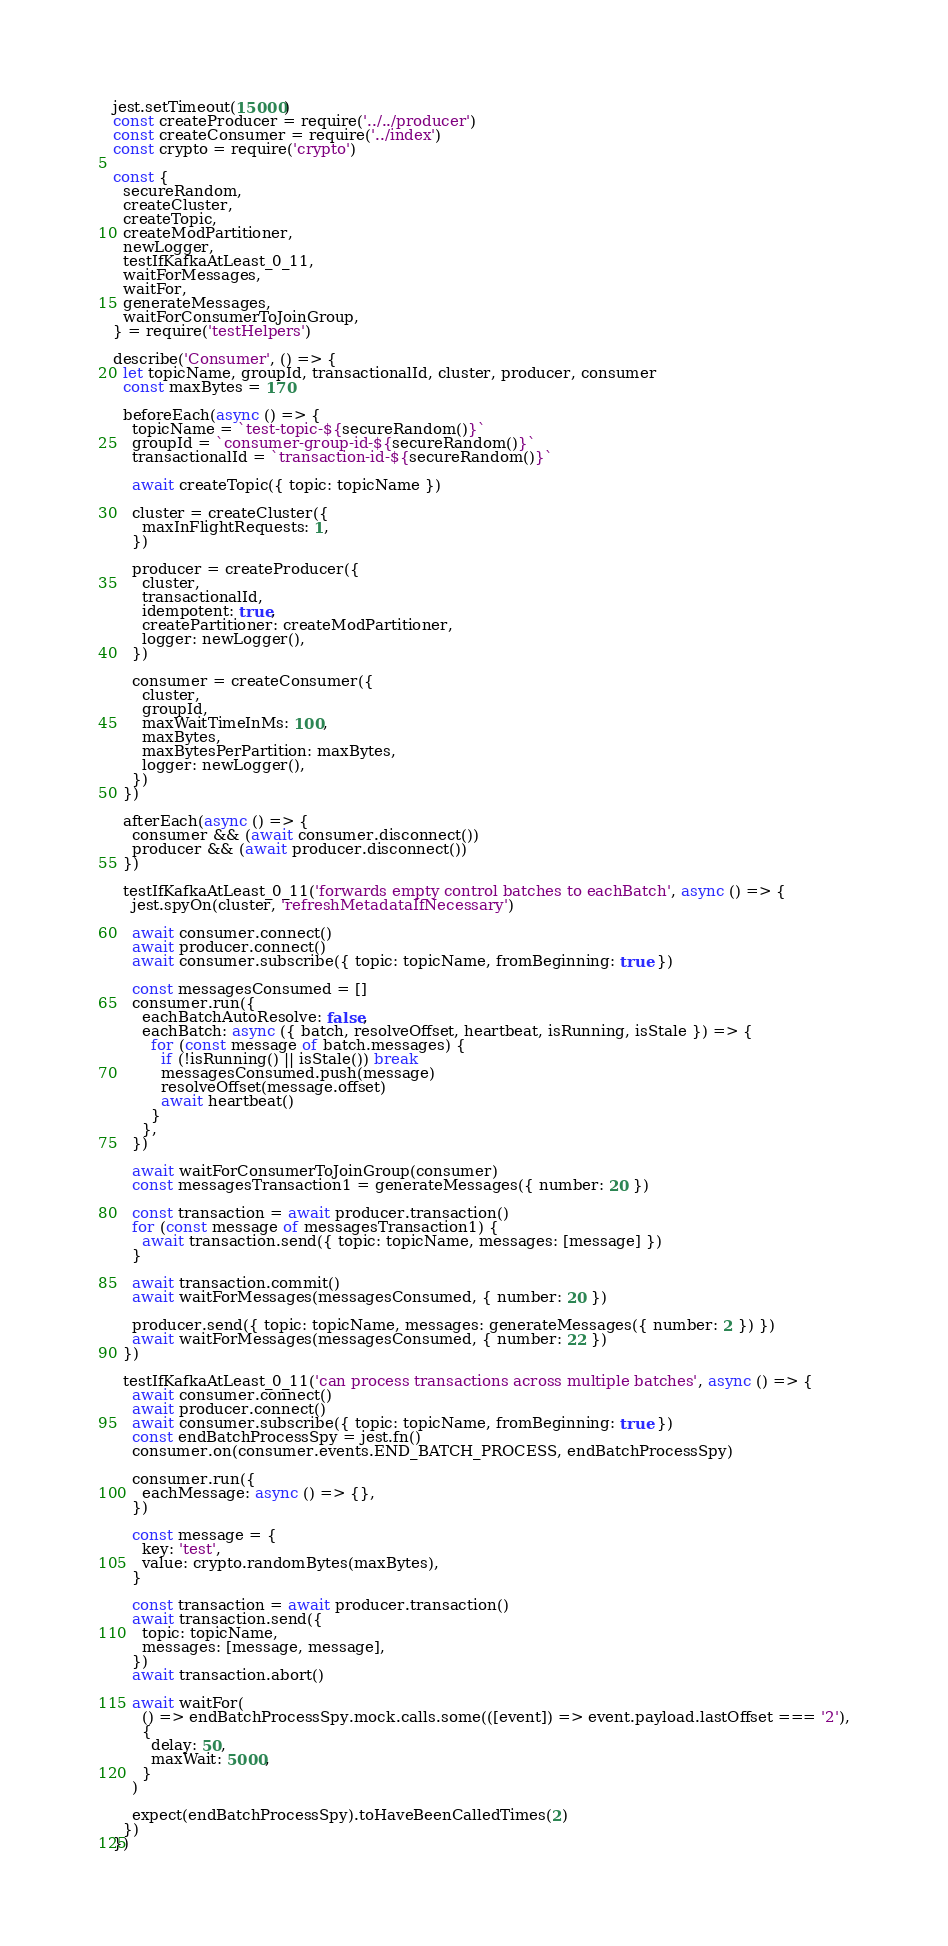<code> <loc_0><loc_0><loc_500><loc_500><_JavaScript_>jest.setTimeout(15000)
const createProducer = require('../../producer')
const createConsumer = require('../index')
const crypto = require('crypto')

const {
  secureRandom,
  createCluster,
  createTopic,
  createModPartitioner,
  newLogger,
  testIfKafkaAtLeast_0_11,
  waitForMessages,
  waitFor,
  generateMessages,
  waitForConsumerToJoinGroup,
} = require('testHelpers')

describe('Consumer', () => {
  let topicName, groupId, transactionalId, cluster, producer, consumer
  const maxBytes = 170

  beforeEach(async () => {
    topicName = `test-topic-${secureRandom()}`
    groupId = `consumer-group-id-${secureRandom()}`
    transactionalId = `transaction-id-${secureRandom()}`

    await createTopic({ topic: topicName })

    cluster = createCluster({
      maxInFlightRequests: 1,
    })

    producer = createProducer({
      cluster,
      transactionalId,
      idempotent: true,
      createPartitioner: createModPartitioner,
      logger: newLogger(),
    })

    consumer = createConsumer({
      cluster,
      groupId,
      maxWaitTimeInMs: 100,
      maxBytes,
      maxBytesPerPartition: maxBytes,
      logger: newLogger(),
    })
  })

  afterEach(async () => {
    consumer && (await consumer.disconnect())
    producer && (await producer.disconnect())
  })

  testIfKafkaAtLeast_0_11('forwards empty control batches to eachBatch', async () => {
    jest.spyOn(cluster, 'refreshMetadataIfNecessary')

    await consumer.connect()
    await producer.connect()
    await consumer.subscribe({ topic: topicName, fromBeginning: true })

    const messagesConsumed = []
    consumer.run({
      eachBatchAutoResolve: false,
      eachBatch: async ({ batch, resolveOffset, heartbeat, isRunning, isStale }) => {
        for (const message of batch.messages) {
          if (!isRunning() || isStale()) break
          messagesConsumed.push(message)
          resolveOffset(message.offset)
          await heartbeat()
        }
      },
    })

    await waitForConsumerToJoinGroup(consumer)
    const messagesTransaction1 = generateMessages({ number: 20 })

    const transaction = await producer.transaction()
    for (const message of messagesTransaction1) {
      await transaction.send({ topic: topicName, messages: [message] })
    }

    await transaction.commit()
    await waitForMessages(messagesConsumed, { number: 20 })

    producer.send({ topic: topicName, messages: generateMessages({ number: 2 }) })
    await waitForMessages(messagesConsumed, { number: 22 })
  })

  testIfKafkaAtLeast_0_11('can process transactions across multiple batches', async () => {
    await consumer.connect()
    await producer.connect()
    await consumer.subscribe({ topic: topicName, fromBeginning: true })
    const endBatchProcessSpy = jest.fn()
    consumer.on(consumer.events.END_BATCH_PROCESS, endBatchProcessSpy)

    consumer.run({
      eachMessage: async () => {},
    })

    const message = {
      key: 'test',
      value: crypto.randomBytes(maxBytes),
    }

    const transaction = await producer.transaction()
    await transaction.send({
      topic: topicName,
      messages: [message, message],
    })
    await transaction.abort()

    await waitFor(
      () => endBatchProcessSpy.mock.calls.some(([event]) => event.payload.lastOffset === '2'),
      {
        delay: 50,
        maxWait: 5000,
      }
    )

    expect(endBatchProcessSpy).toHaveBeenCalledTimes(2)
  })
})
</code> 